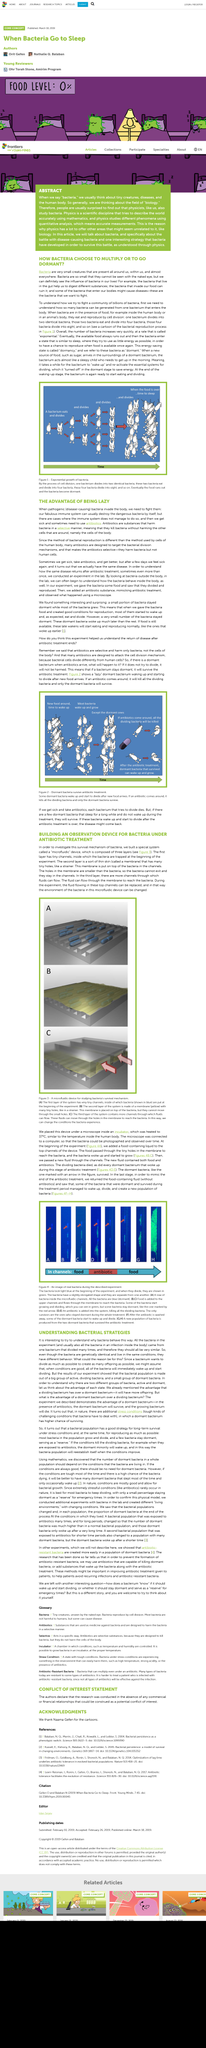Identify some key points in this picture. Figure 3 shows a microfluidic device that illustrates the method used to study bacteria's survival mechanism. Antibiotics are drugs that aim to disrupt the growth and division of bacteria, making them ineffective at causing harm. Antibiotics are often effective at killing bacteria, however, some bacteria are able to survive treatment by entering a dormant state. These dormant bacteria are able to remain inactive until conditions become favorable for growth, at which point they can wake up and begin to multiply once again. Therefore, it is possible for some bacteria to survive antibiotic treatment. Bacteria exhibit a high rate of growth through exponential growth, which is characterized by an exponential increase in population size over time. The above image depicts actual bacteria from the prescribed experiment, showcasing the real-life representation of the subject matter. 